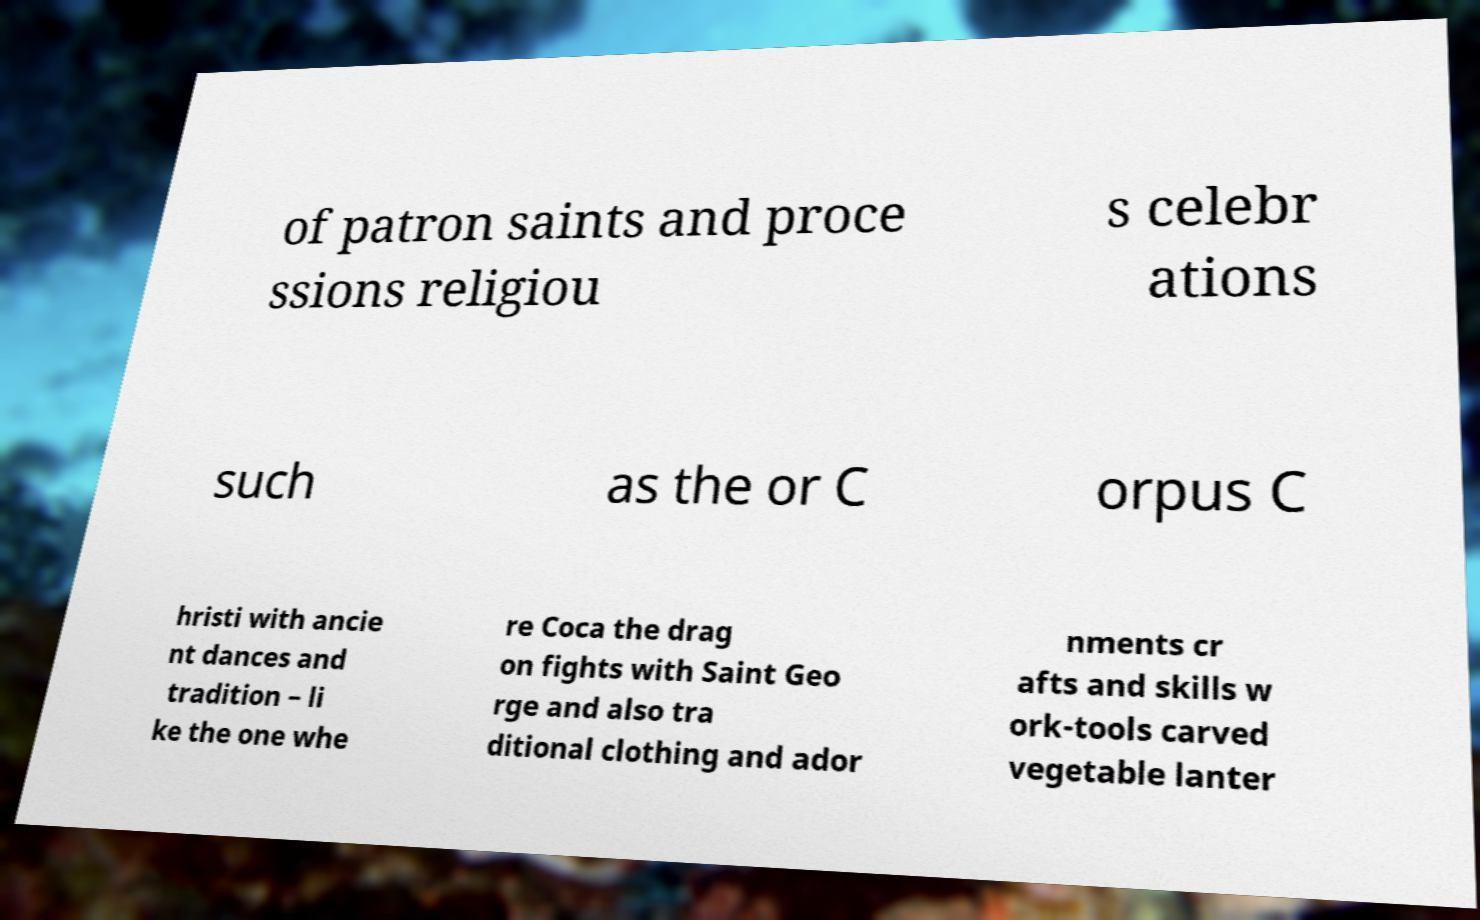Could you assist in decoding the text presented in this image and type it out clearly? of patron saints and proce ssions religiou s celebr ations such as the or C orpus C hristi with ancie nt dances and tradition – li ke the one whe re Coca the drag on fights with Saint Geo rge and also tra ditional clothing and ador nments cr afts and skills w ork-tools carved vegetable lanter 